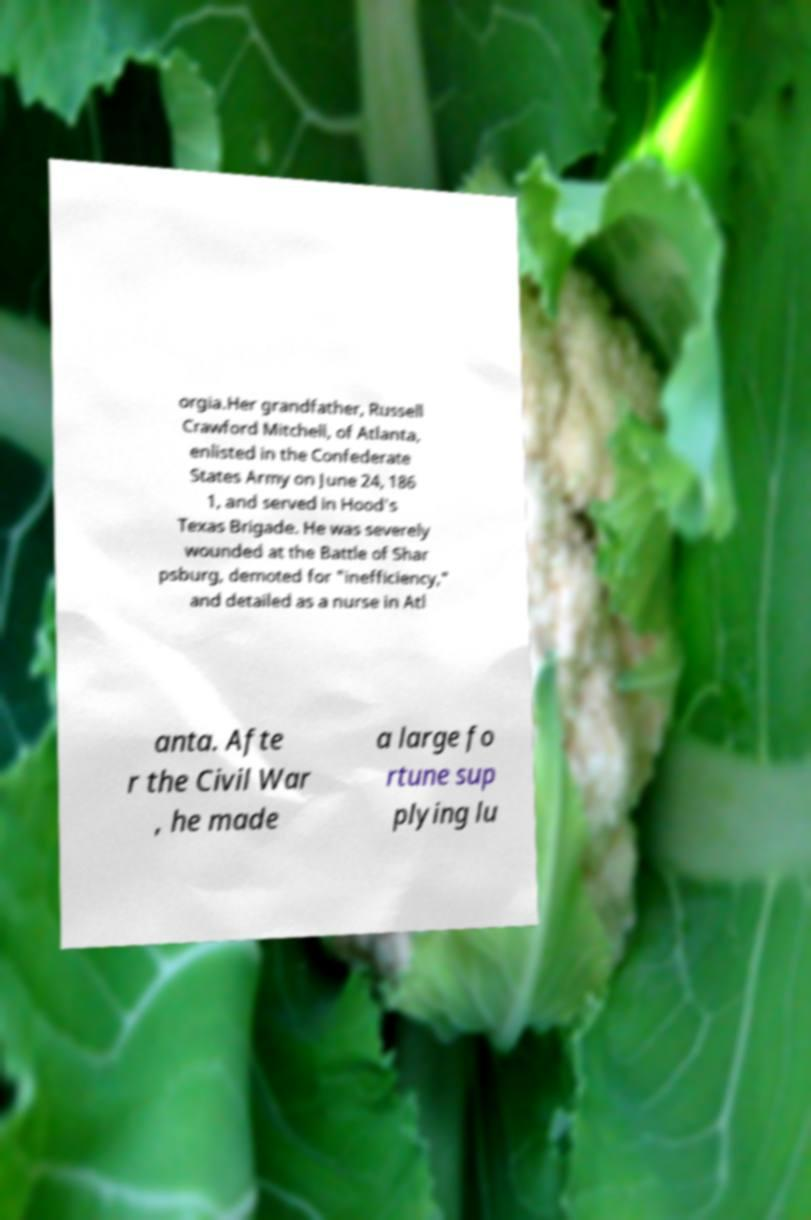What messages or text are displayed in this image? I need them in a readable, typed format. orgia.Her grandfather, Russell Crawford Mitchell, of Atlanta, enlisted in the Confederate States Army on June 24, 186 1, and served in Hood's Texas Brigade. He was severely wounded at the Battle of Shar psburg, demoted for "inefficiency," and detailed as a nurse in Atl anta. Afte r the Civil War , he made a large fo rtune sup plying lu 